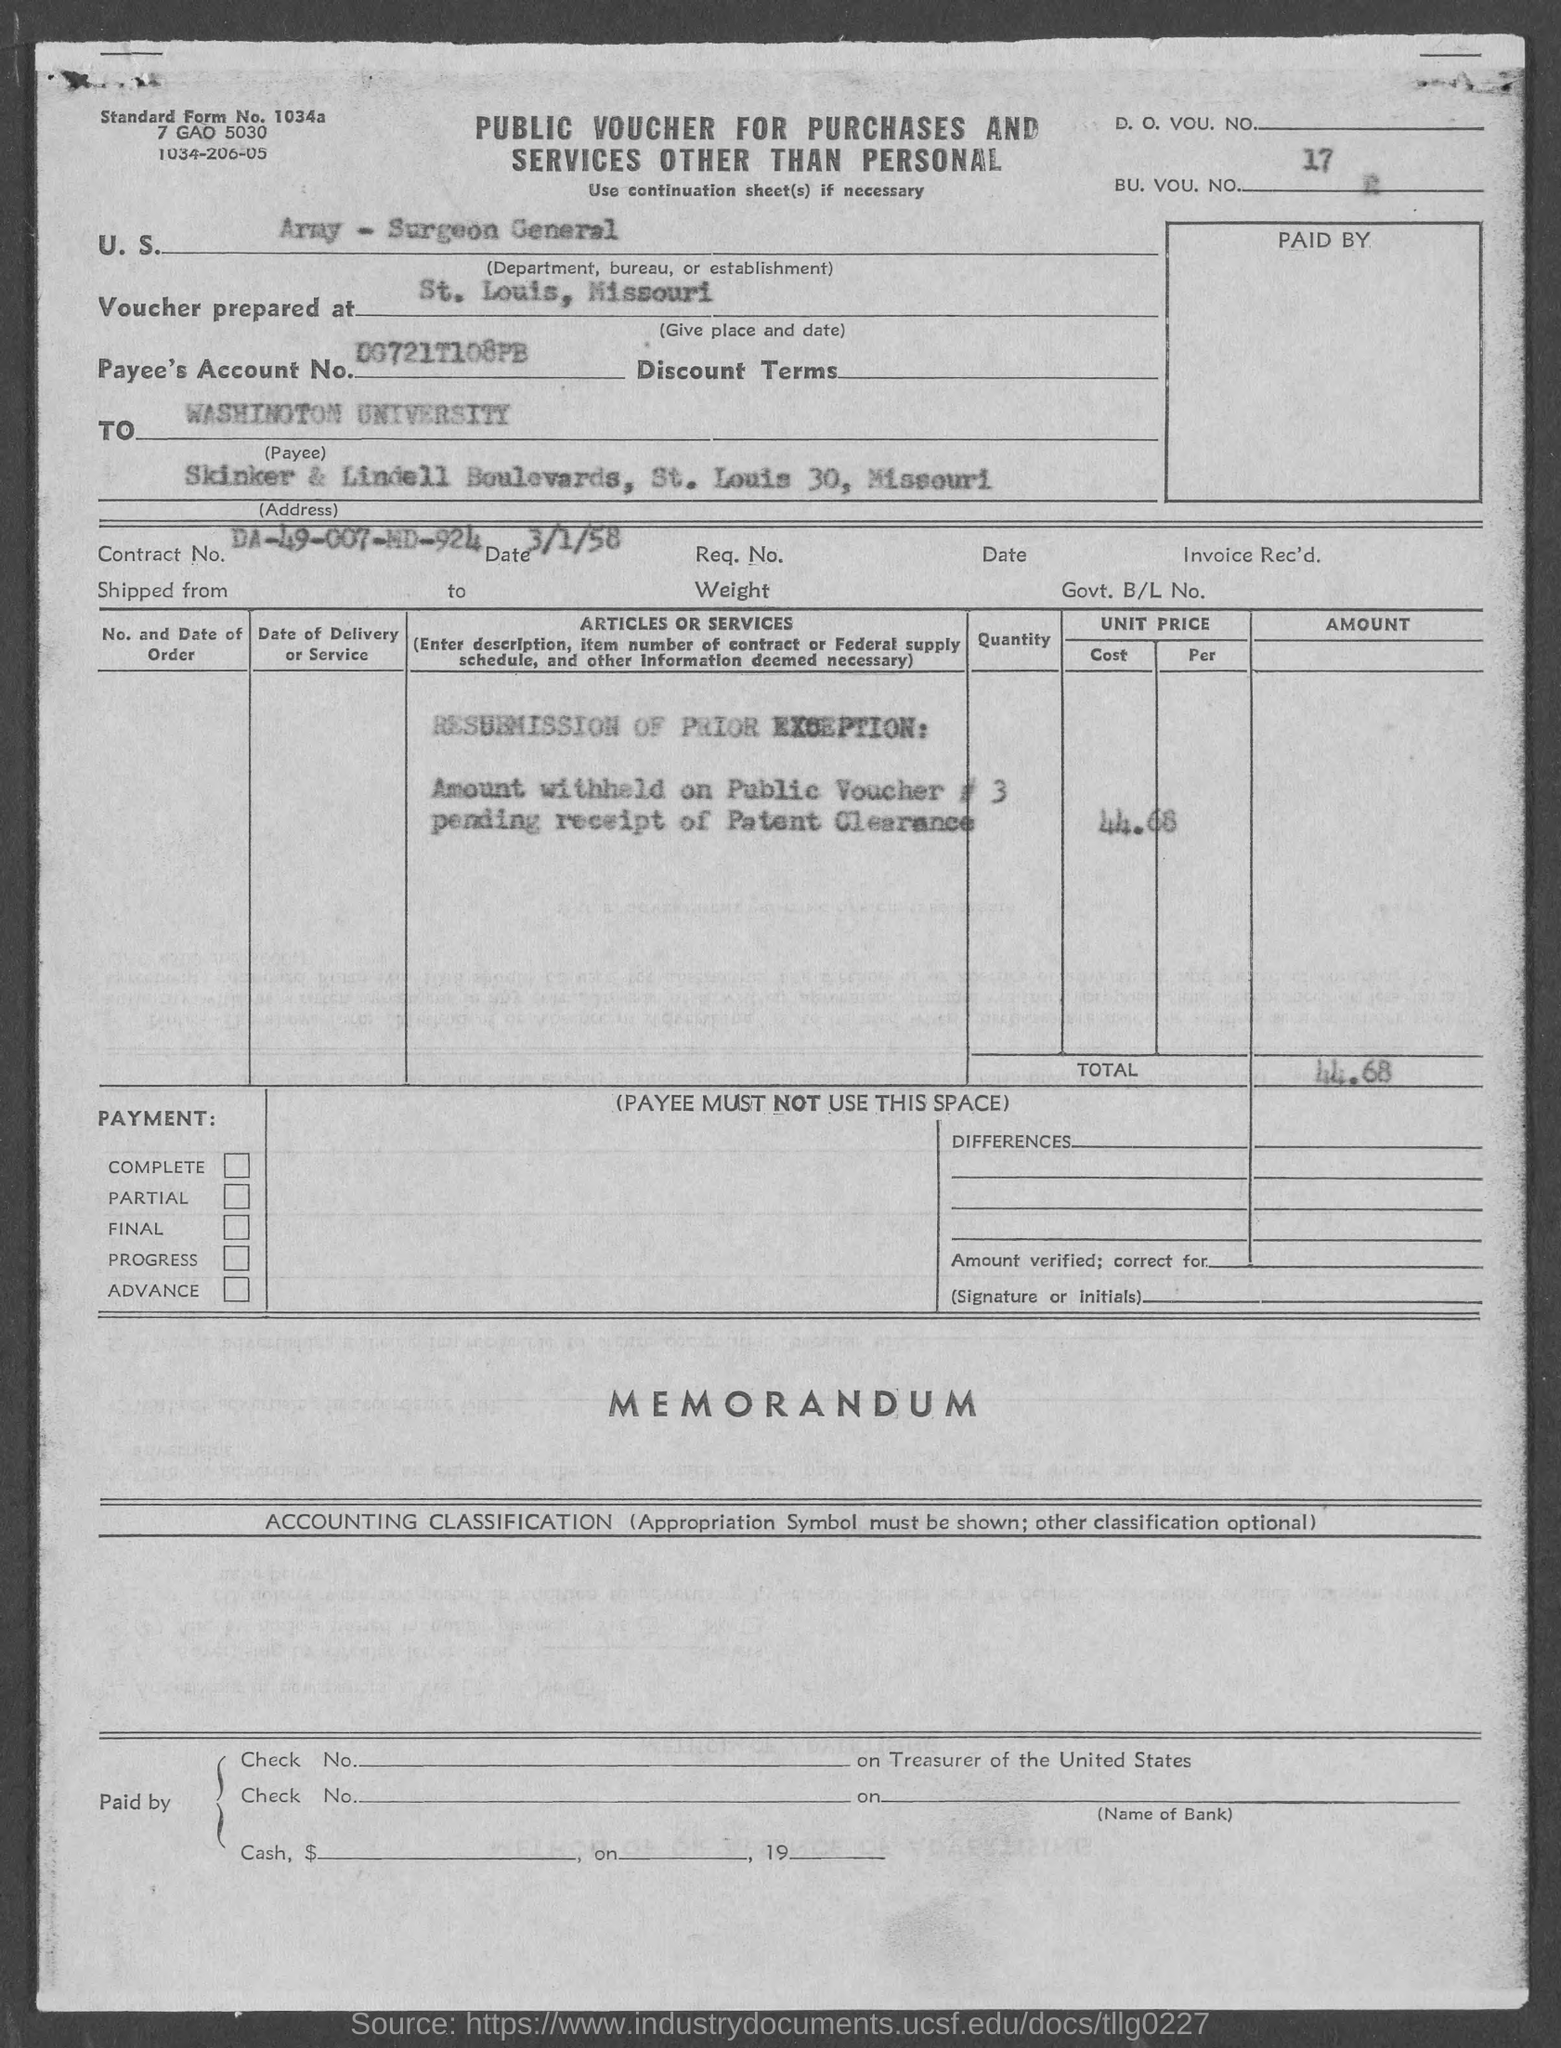List a handful of essential elements in this visual. The contract number mentioned in the given form is DA-49-007-MD-924. What is the date mentioned in the given form, which is 3/1/58? The Surgeon General is a department, bureau, or establishment within the Army. The university mentioned in the given form is Washington University. The total amount mentioned in the given form is 44.68. 